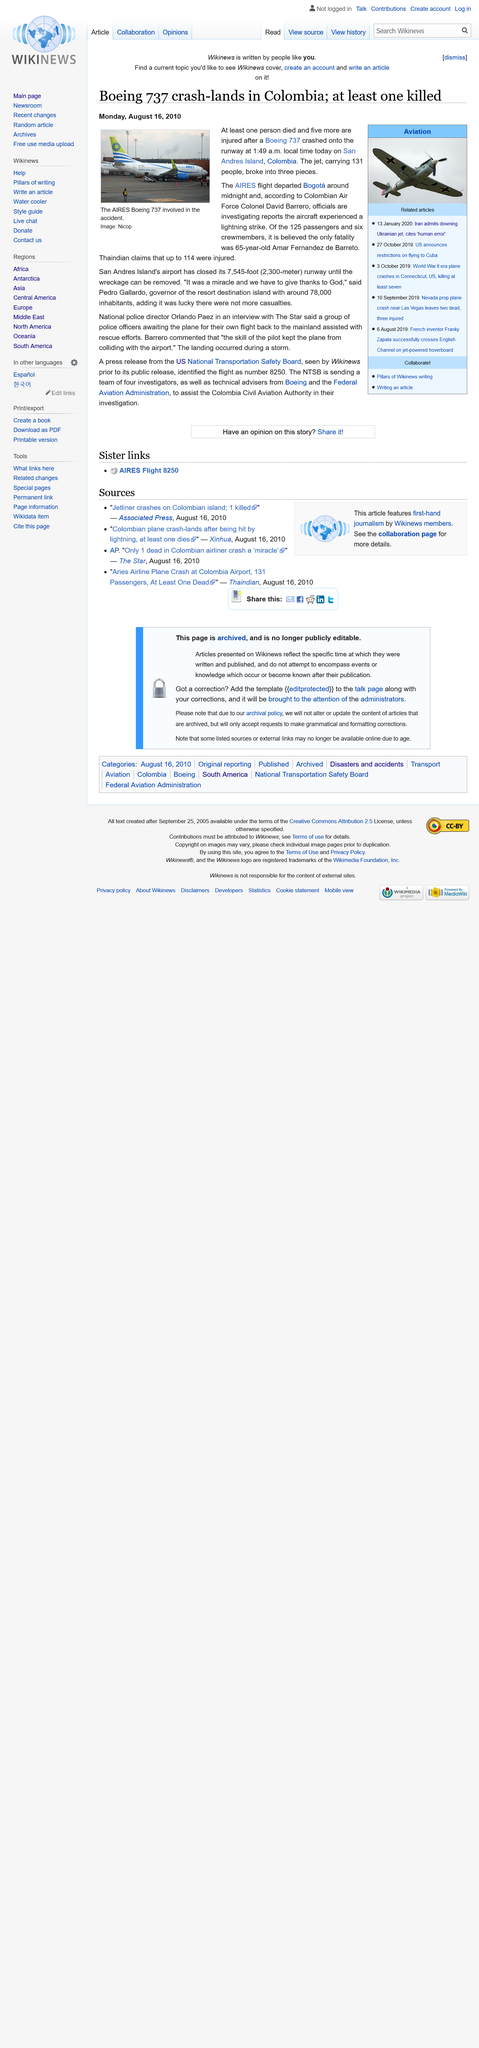Mention a couple of crucial points in this snapshot. On February 4th, a Boeing 737 carrying 131 passengers was involved in a crash in Columbia. The jet was carrying a large number of passengers, and investigators are working to determine the cause of the crash. At least one person died in the Boeing 737 crash in Colombia. On February 3, 2021, an Aires flight crashed in Colombia, killing all 136 people on board. The AIRES aircraft was a Boeing 737, which was involved in the accident. 